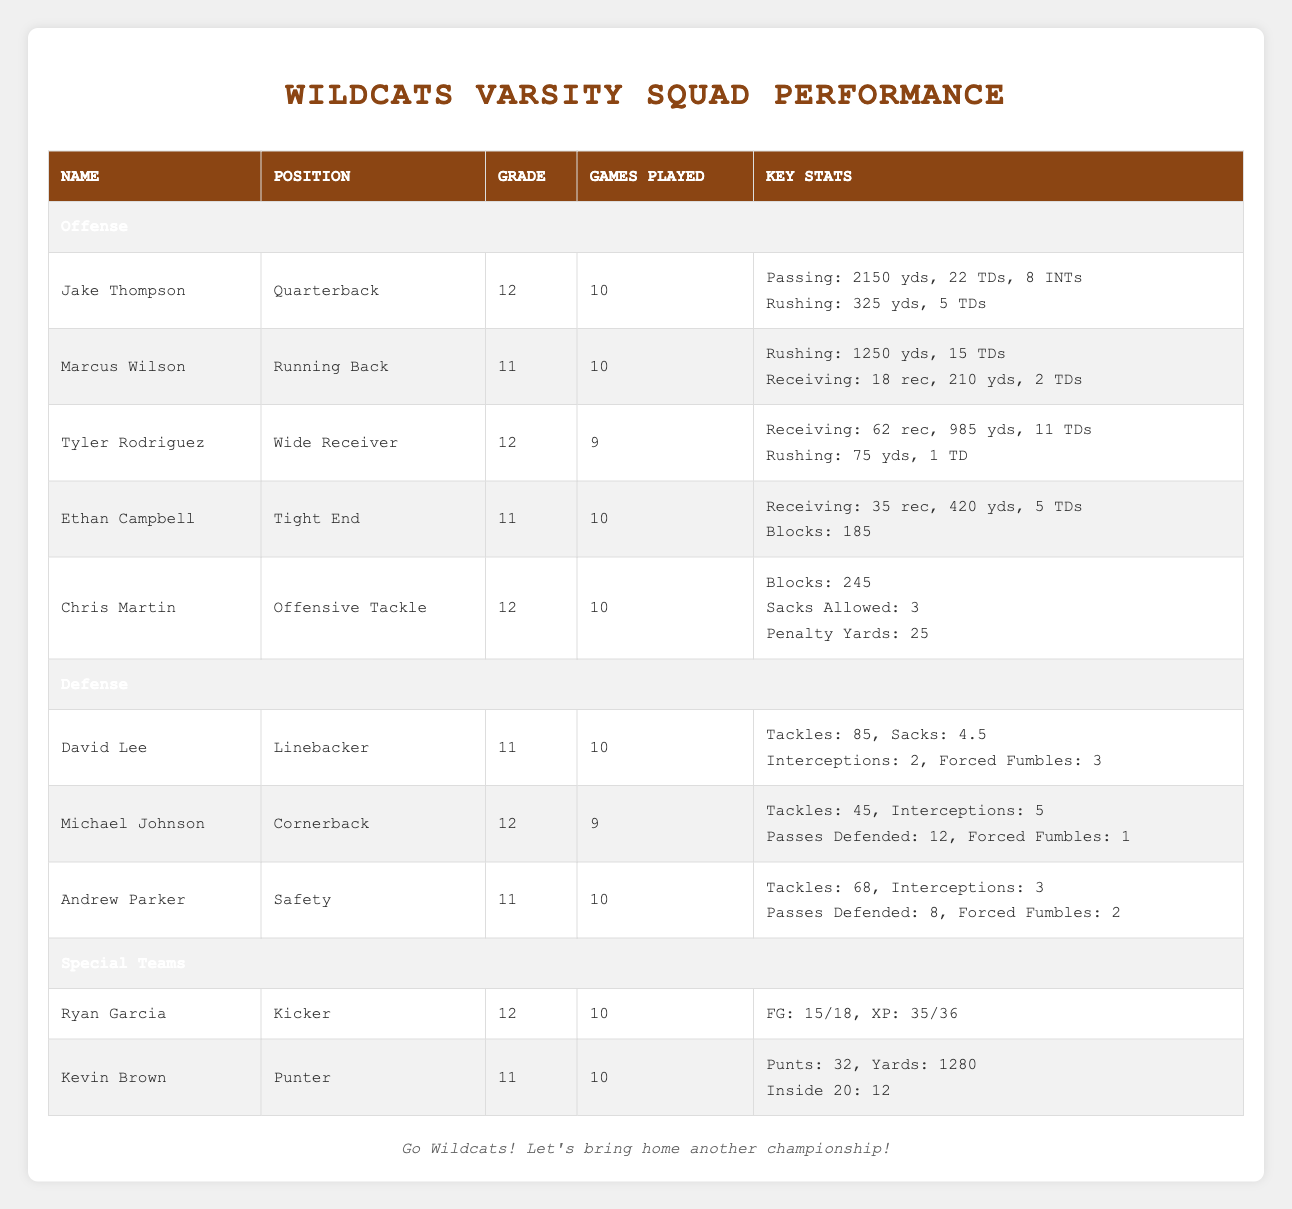What is the total number of touchdowns scored by Jake Thompson? Jake Thompson has 22 passing touchdowns and 5 rushing touchdowns. To find the total, I add them together: 22 + 5 = 27.
Answer: 27 Which player has the most rushing yards? Marcus Wilson has 1250 rushing yards, while the next closest is Jake Thompson with 325 rushing yards. Therefore, Marcus Wilson has the most rushing yards.
Answer: Marcus Wilson How many games did Tyler Rodriguez play? The table explicitly states that Tyler Rodriguez played 9 games.
Answer: 9 Is it true that Andrew Parker recorded more tackles than Michael Johnson? Andrew Parker has 68 tackles, while Michael Johnson has 45 tackles. Since 68 is greater than 45, it is true that Andrew Parker recorded more tackles.
Answer: Yes What is the average number of games played by the players? The total number of games played by the 10 players is 10 (Jake) + 10 (Marcus) + 9 (Tyler) + 10 (Ethan) + 10 (Chris) + 10 (David) + 9 (Michael) + 10 (Andrew) + 10 (Ryan) + 10 (Kevin) = 99 games. There are 10 players, so the average is 99 / 10 = 9.9.
Answer: 9.9 How many interceptions did David Lee have? The table states David Lee had 2 interceptions.
Answer: 2 What is the total number of field goals Ryan Garcia made this season? Ryan Garcia made a total of 15 field goals according to the table.
Answer: 15 Which position has the most players listed in the table, and how many players are in that position? There are 5 players listed under offense (Quarterback, Running Back, Wide Receiver, Tight End, Offensive Tackle) and 3 players under defense (Linebacker, Cornerback, Safety). Since 5 > 3, offense has the most players.
Answer: Offense, 5 players What is the difference in passing touchdowns between Jake Thompson and Tyler Rodriguez? Jake Thompson has 22 passing touchdowns, while Tyler Rodriguez has none since he is categorized as a wide receiver and no passing touchdowns are mentioned. The difference is 22 - 0 = 22.
Answer: 22 